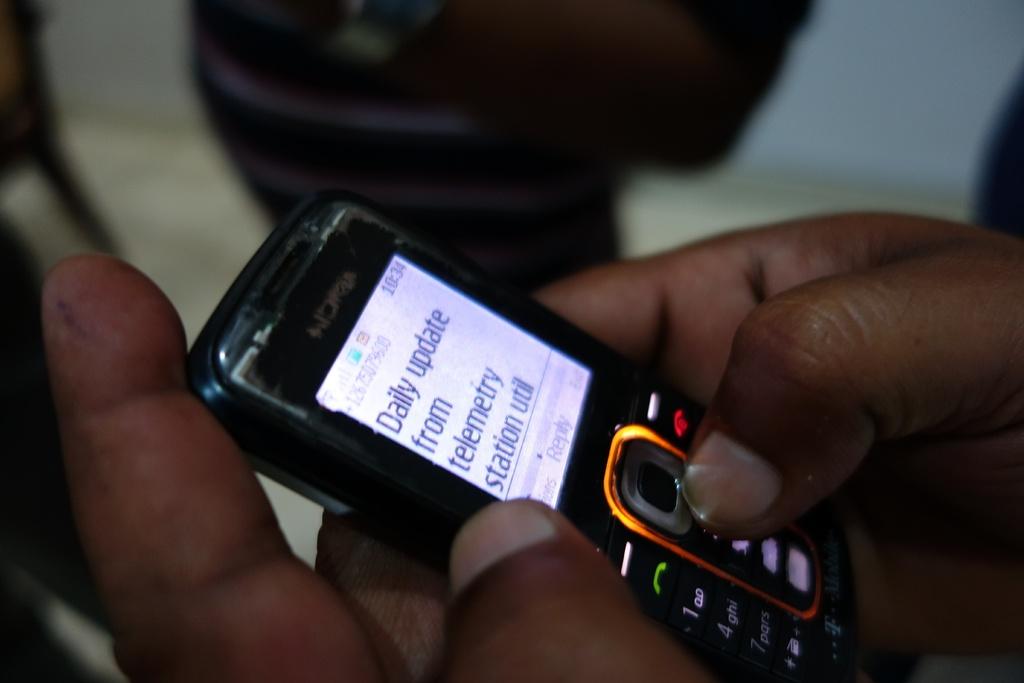What kind of updates?
Offer a terse response. Daily. 